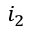Convert formula to latex. <formula><loc_0><loc_0><loc_500><loc_500>i _ { 2 }</formula> 